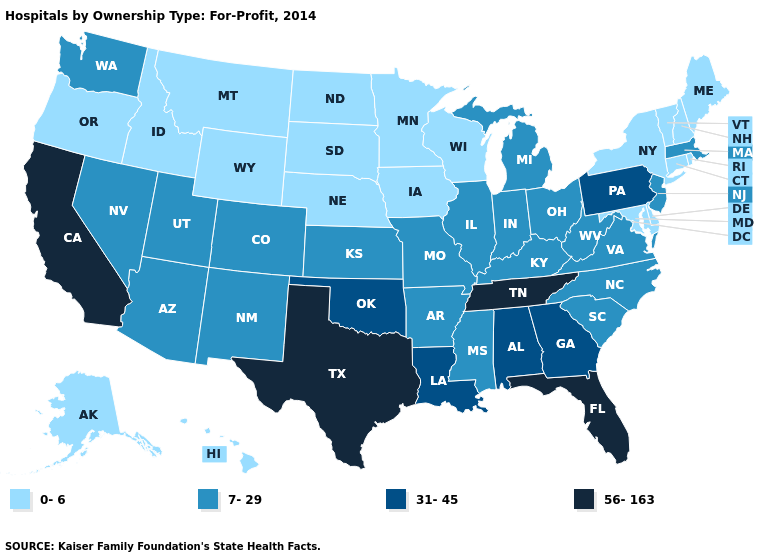Does Hawaii have the highest value in the West?
Be succinct. No. What is the value of Arkansas?
Concise answer only. 7-29. Which states hav the highest value in the MidWest?
Quick response, please. Illinois, Indiana, Kansas, Michigan, Missouri, Ohio. Name the states that have a value in the range 0-6?
Keep it brief. Alaska, Connecticut, Delaware, Hawaii, Idaho, Iowa, Maine, Maryland, Minnesota, Montana, Nebraska, New Hampshire, New York, North Dakota, Oregon, Rhode Island, South Dakota, Vermont, Wisconsin, Wyoming. What is the highest value in the USA?
Quick response, please. 56-163. Which states have the lowest value in the West?
Short answer required. Alaska, Hawaii, Idaho, Montana, Oregon, Wyoming. Which states hav the highest value in the Northeast?
Short answer required. Pennsylvania. Does Pennsylvania have the highest value in the Northeast?
Quick response, please. Yes. Name the states that have a value in the range 31-45?
Keep it brief. Alabama, Georgia, Louisiana, Oklahoma, Pennsylvania. How many symbols are there in the legend?
Give a very brief answer. 4. What is the value of Nebraska?
Short answer required. 0-6. What is the value of Mississippi?
Concise answer only. 7-29. Name the states that have a value in the range 7-29?
Concise answer only. Arizona, Arkansas, Colorado, Illinois, Indiana, Kansas, Kentucky, Massachusetts, Michigan, Mississippi, Missouri, Nevada, New Jersey, New Mexico, North Carolina, Ohio, South Carolina, Utah, Virginia, Washington, West Virginia. Does Delaware have the same value as Oklahoma?
Give a very brief answer. No. 